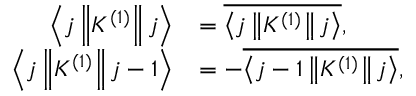Convert formula to latex. <formula><loc_0><loc_0><loc_500><loc_500>{ \begin{array} { r l } { \left \langle j \left \| K ^ { ( 1 ) } \right \| j \right \rangle } & { = { \overline { { \left \langle j \left \| K ^ { ( 1 ) } \right \| j \right \rangle } } } , } \\ { \left \langle j \left \| K ^ { ( 1 ) } \right \| j - 1 \right \rangle } & { = - { \overline { { \left \langle j - 1 \left \| K ^ { ( 1 ) } \right \| j \right \rangle } } } , } \end{array} }</formula> 